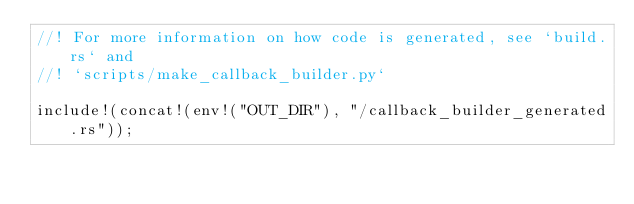<code> <loc_0><loc_0><loc_500><loc_500><_Rust_>//! For more information on how code is generated, see `build.rs` and
//! `scripts/make_callback_builder.py`

include!(concat!(env!("OUT_DIR"), "/callback_builder_generated.rs"));
</code> 